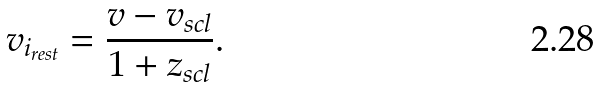<formula> <loc_0><loc_0><loc_500><loc_500>v _ { i _ { r e s t } } = \frac { v - v _ { s c l } } { 1 + z _ { s c l } } .</formula> 